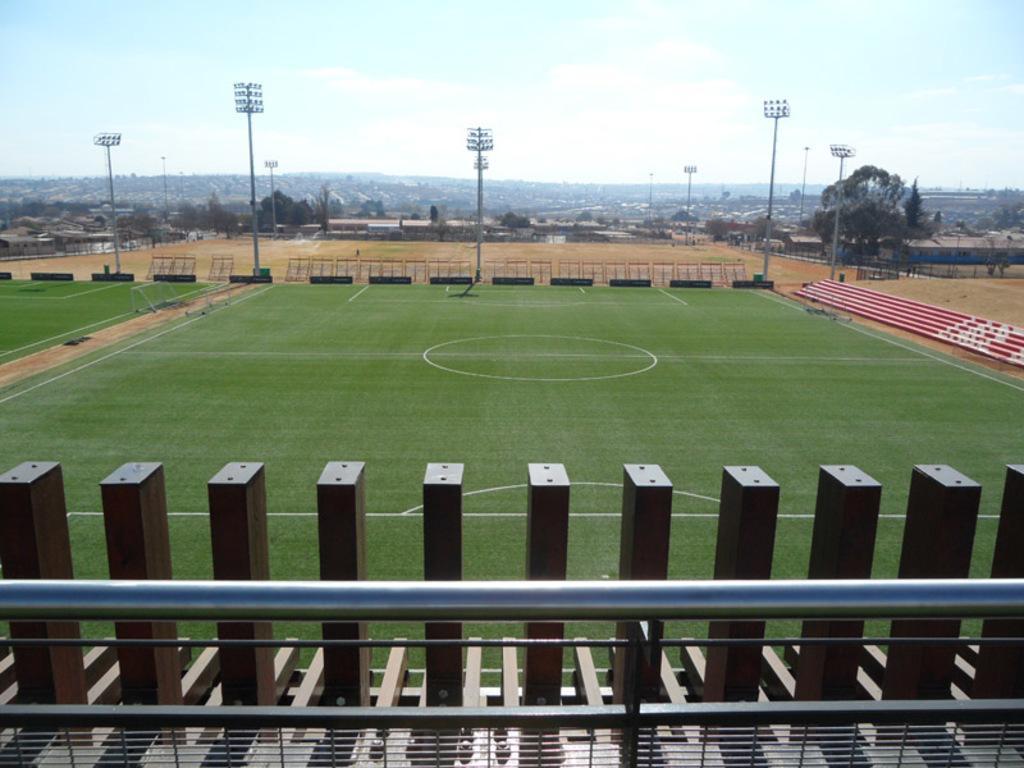How would you summarize this image in a sentence or two? In this image, I can see the ground, flood lights to the poles, stairs and few objects. At the bottom of the image, I can see railing and wooden poles. In the background there are trees, sheds and the sky. 